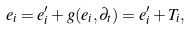Convert formula to latex. <formula><loc_0><loc_0><loc_500><loc_500>e _ { i } = e _ { i } ^ { \prime } + g ( e _ { i } , \partial _ { t } ) = e _ { i } ^ { \prime } + T _ { i } ,</formula> 